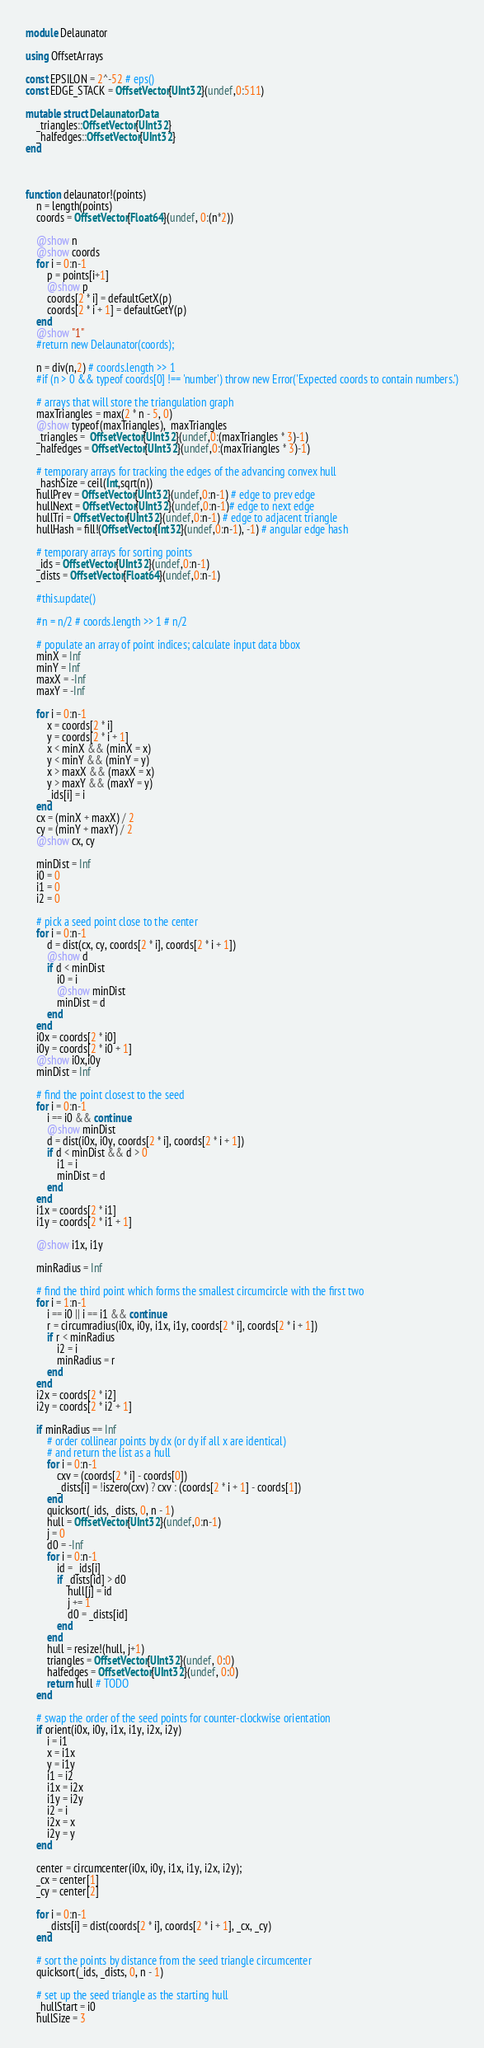Convert code to text. <code><loc_0><loc_0><loc_500><loc_500><_Julia_>module Delaunator

using OffsetArrays

const EPSILON = 2^-52 # eps()
const EDGE_STACK = OffsetVector{UInt32}(undef,0:511)

mutable struct DelaunatorData
    _triangles::OffsetVector{UInt32}
    _halfedges::OffsetVector{UInt32}
end



function delaunator!(points)
    n = length(points)
    coords = OffsetVector{Float64}(undef, 0:(n*2))

    @show n
    @show coords
    for i = 0:n-1
        p = points[i+1]
        @show p
        coords[2 * i] = defaultGetX(p)
        coords[2 * i + 1] = defaultGetY(p)
    end
    @show "1"
    #return new Delaunator(coords);

    n = div(n,2) # coords.length >> 1
    #if (n > 0 && typeof coords[0] !== 'number') throw new Error('Expected coords to contain numbers.')

    # arrays that will store the triangulation graph
    maxTriangles = max(2 * n - 5, 0)
    @show typeof(maxTriangles),  maxTriangles
    _triangles =  OffsetVector{UInt32}(undef,0:(maxTriangles * 3)-1)
    _halfedges = OffsetVector{UInt32}(undef,0:(maxTriangles * 3)-1)

    # temporary arrays for tracking the edges of the advancing convex hull
    _hashSize = ceil(Int,sqrt(n))
    hullPrev = OffsetVector{UInt32}(undef,0:n-1) # edge to prev edge
    hullNext = OffsetVector{UInt32}(undef,0:n-1)# edge to next edge
    hullTri = OffsetVector{UInt32}(undef,0:n-1) # edge to adjacent triangle
    hullHash = fill!(OffsetVector{Int32}(undef,0:n-1), -1) # angular edge hash

    # temporary arrays for sorting points
    _ids = OffsetVector{UInt32}(undef,0:n-1)
    _dists = OffsetVector{Float64}(undef,0:n-1)

    #this.update()

    #n = n/2 # coords.length >> 1 # n/2

    # populate an array of point indices; calculate input data bbox
    minX = Inf
    minY = Inf
    maxX = -Inf
    maxY = -Inf

    for i = 0:n-1
        x = coords[2 * i]
        y = coords[2 * i + 1]
        x < minX && (minX = x)
        y < minY && (minY = y)
        x > maxX && (maxX = x)
        y > maxY && (maxY = y)
        _ids[i] = i
    end
    cx = (minX + maxX) / 2
    cy = (minY + maxY) / 2
    @show cx, cy

    minDist = Inf
    i0 = 0
    i1 = 0
    i2 = 0

    # pick a seed point close to the center
    for i = 0:n-1
        d = dist(cx, cy, coords[2 * i], coords[2 * i + 1])
        @show d
        if d < minDist
            i0 = i
            @show minDist
            minDist = d
        end
    end
    i0x = coords[2 * i0]
    i0y = coords[2 * i0 + 1]
    @show i0x,i0y
    minDist = Inf

    # find the point closest to the seed
    for i = 0:n-1
        i == i0 && continue
        @show minDist
        d = dist(i0x, i0y, coords[2 * i], coords[2 * i + 1])
        if d < minDist && d > 0
            i1 = i
            minDist = d
        end
    end
    i1x = coords[2 * i1]
    i1y = coords[2 * i1 + 1]

    @show i1x, i1y

    minRadius = Inf

    # find the third point which forms the smallest circumcircle with the first two
    for i = 1:n-1
        i == i0 || i == i1 && continue
        r = circumradius(i0x, i0y, i1x, i1y, coords[2 * i], coords[2 * i + 1])
        if r < minRadius
            i2 = i
            minRadius = r
        end
    end
    i2x = coords[2 * i2]
    i2y = coords[2 * i2 + 1]

    if minRadius == Inf
        # order collinear points by dx (or dy if all x are identical)
        # and return the list as a hull
        for i = 0:n-1
            cxv = (coords[2 * i] - coords[0])
            _dists[i] = !iszero(cxv) ? cxv : (coords[2 * i + 1] - coords[1])
        end
        quicksort(_ids, _dists, 0, n - 1)
        hull = OffsetVector{UInt32}(undef,0:n-1)
        j = 0
        d0 = -Inf
        for i = 0:n-1
            id = _ids[i]
            if _dists[id] > d0
                hull[j] = id
                j += 1
                d0 = _dists[id]
            end
        end
        hull = resize!(hull, j+1)
        triangles = OffsetVector{UInt32}(undef, 0:0)
        halfedges = OffsetVector{UInt32}(undef, 0:0)
        return hull # TODO
    end

    # swap the order of the seed points for counter-clockwise orientation
    if orient(i0x, i0y, i1x, i1y, i2x, i2y)
        i = i1
        x = i1x
        y = i1y
        i1 = i2
        i1x = i2x
        i1y = i2y
        i2 = i
        i2x = x
        i2y = y
    end

    center = circumcenter(i0x, i0y, i1x, i1y, i2x, i2y);
    _cx = center[1]
    _cy = center[2]

    for i = 0:n-1
        _dists[i] = dist(coords[2 * i], coords[2 * i + 1], _cx, _cy)
    end

    # sort the points by distance from the seed triangle circumcenter
    quicksort(_ids, _dists, 0, n - 1)

    # set up the seed triangle as the starting hull
    _hullStart = i0
    hullSize = 3
</code> 